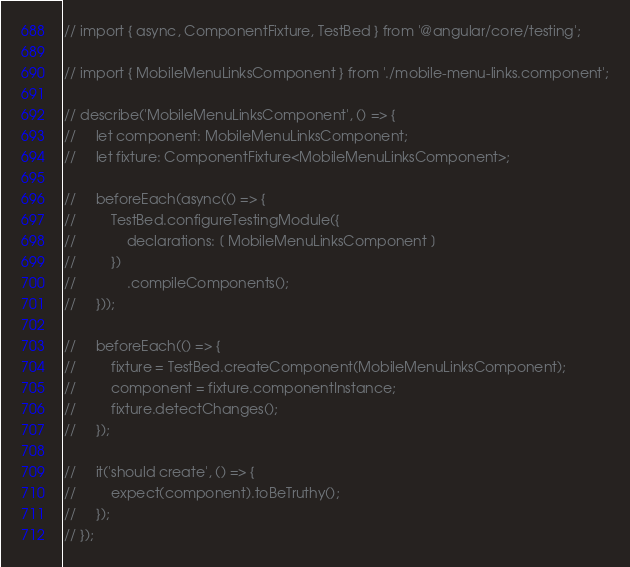<code> <loc_0><loc_0><loc_500><loc_500><_TypeScript_>// import { async, ComponentFixture, TestBed } from '@angular/core/testing';

// import { MobileMenuLinksComponent } from './mobile-menu-links.component';

// describe('MobileMenuLinksComponent', () => {
//     let component: MobileMenuLinksComponent;
//     let fixture: ComponentFixture<MobileMenuLinksComponent>;

//     beforeEach(async(() => {
//         TestBed.configureTestingModule({
//             declarations: [ MobileMenuLinksComponent ]
//         })
//             .compileComponents();
//     }));

//     beforeEach(() => {
//         fixture = TestBed.createComponent(MobileMenuLinksComponent);
//         component = fixture.componentInstance;
//         fixture.detectChanges();
//     });

//     it('should create', () => {
//         expect(component).toBeTruthy();
//     });
// });
</code> 